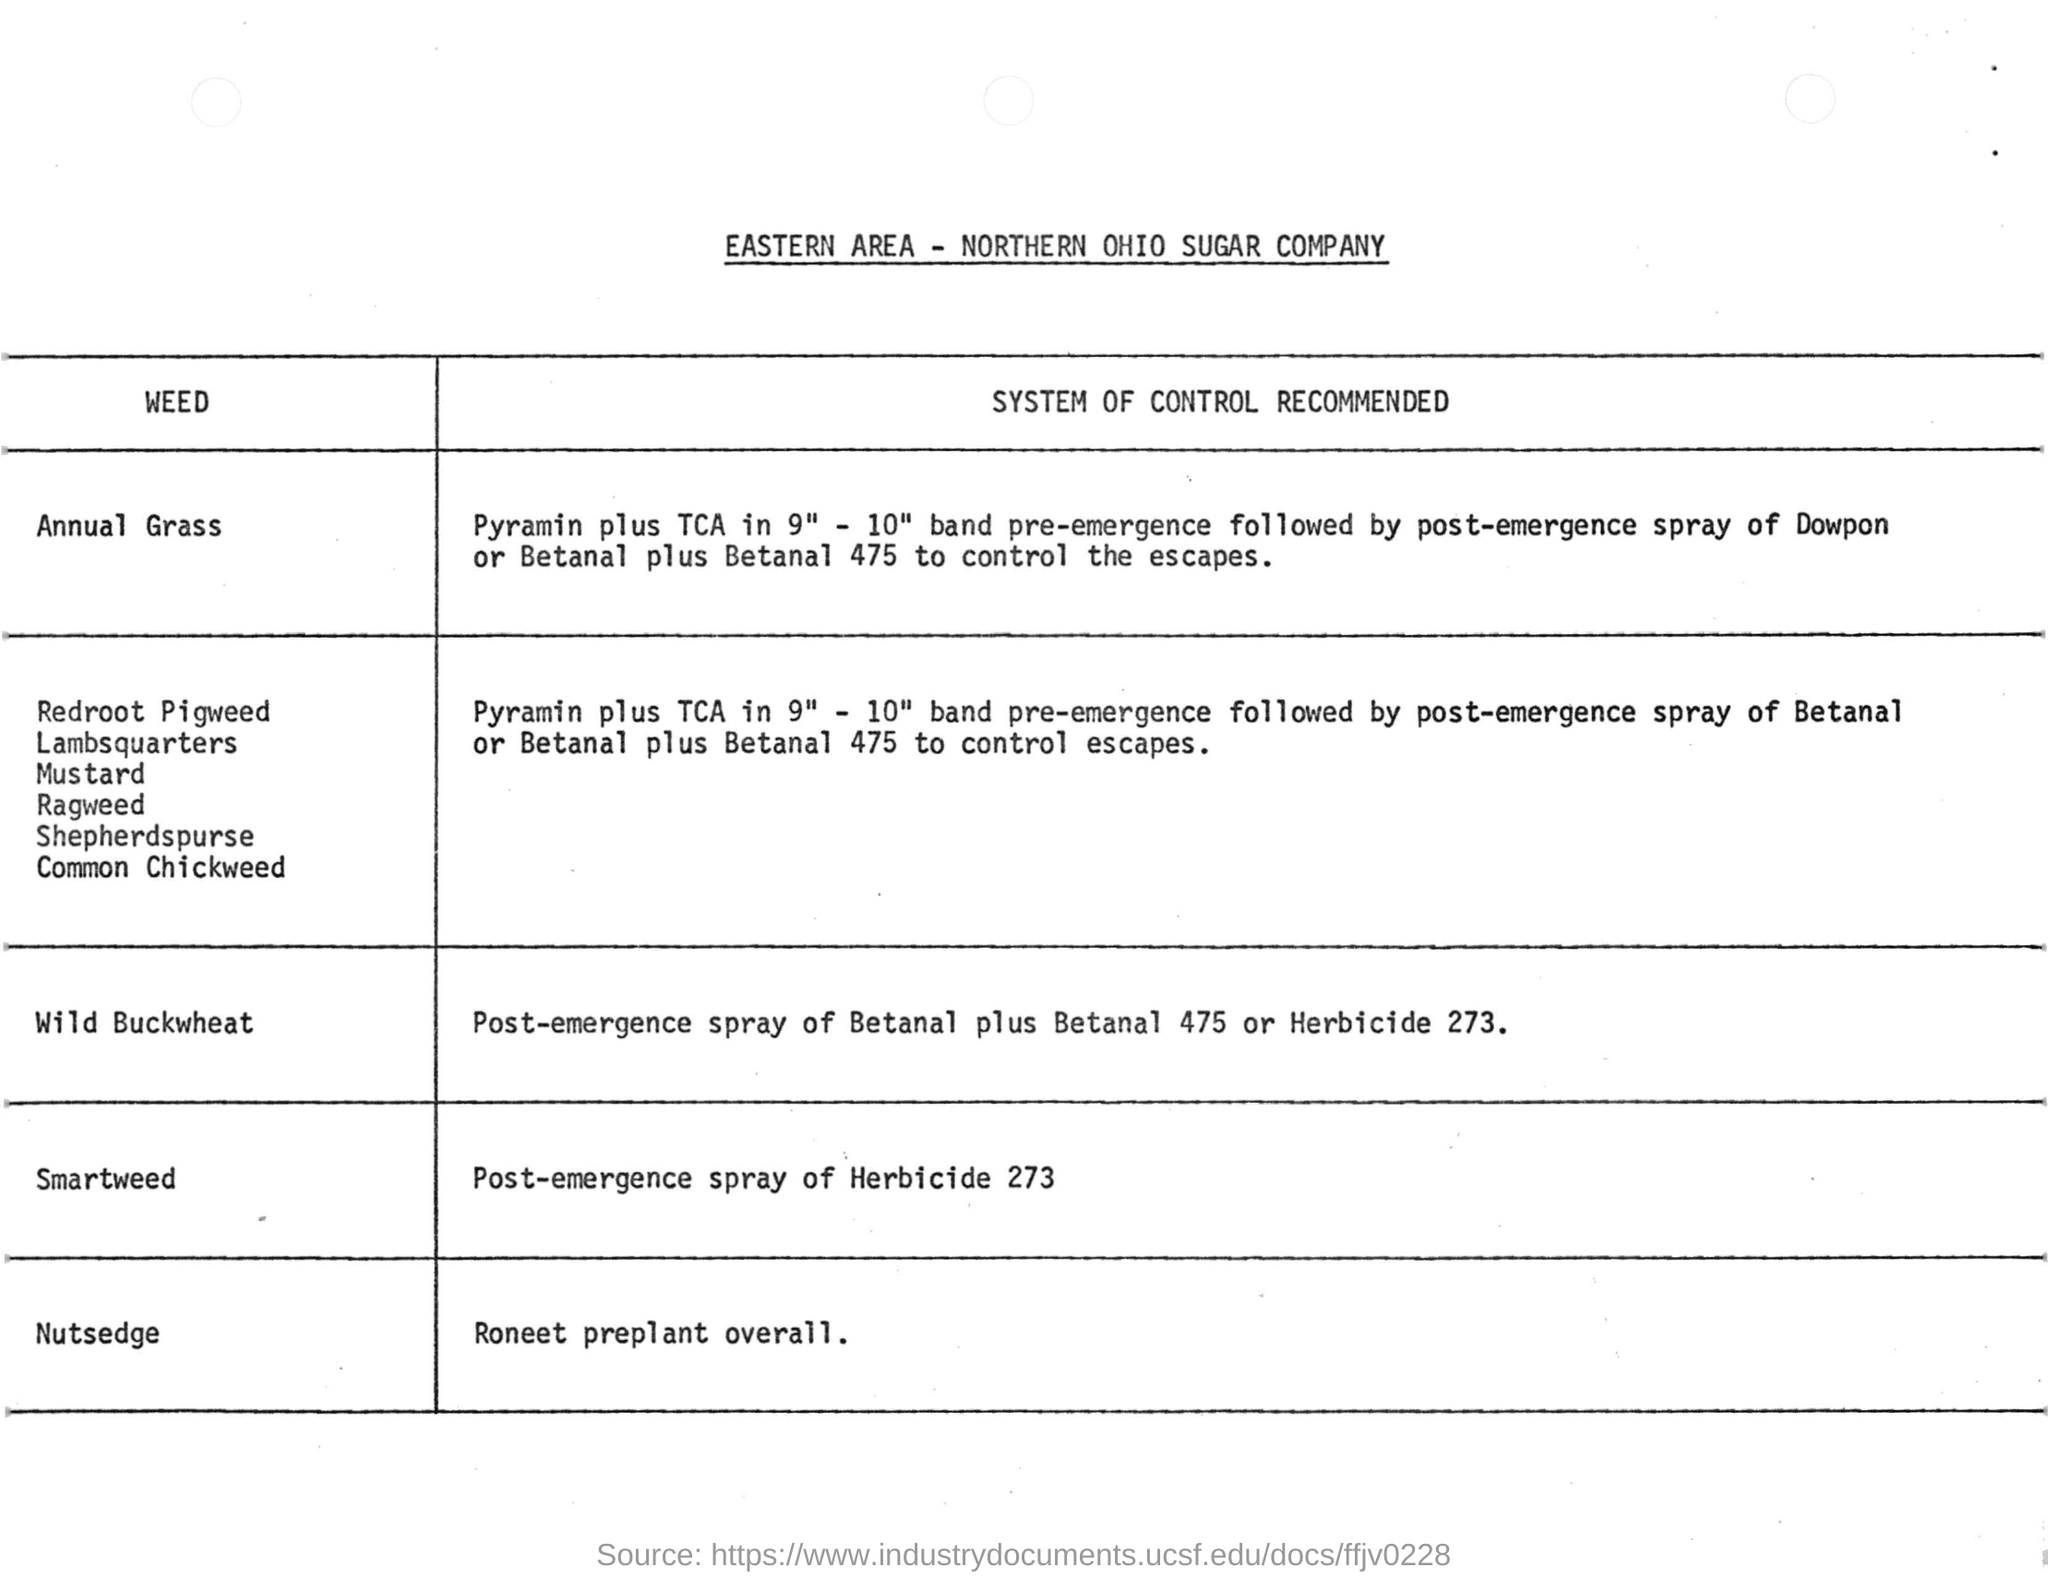List a handful of essential elements in this visual. Dowpon is recommended for post-emergence control of annual grass weeds in crops. The document mentions the name of the Northern Ohio Sugar Company. The recommended system of control for nutsedge, as recommended by Roneet for preplant application, is... After emergence, the recommended herbicide for controlling smartweed is Herbicide 273. 